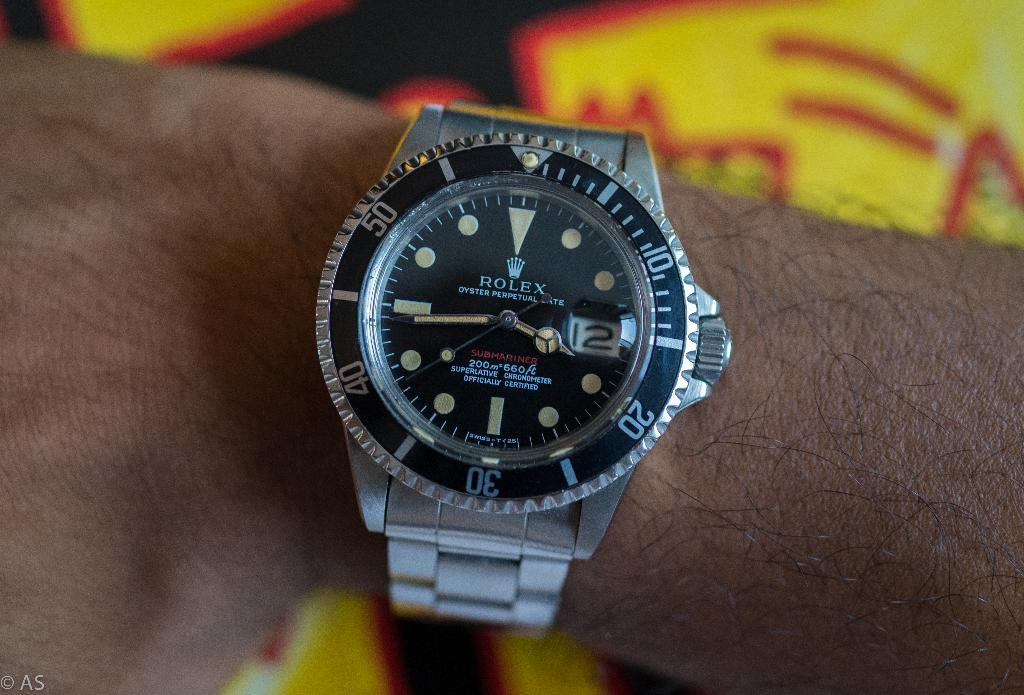What is present in the image? There is a person in the image. What can be seen on the person's wrist? The person is wearing a silver color watch. What features are present on the watch? The watch has numbers on it and there is text on the watch. What else can be seen at the bottom of the image? There appear to be papers at the bottom of the image. How many eggs are being cooked by the frogs in the image? There are no frogs or eggs present in the image. What type of butter is being used to butter the toast in the image? There is no toast or butter present in the image. 